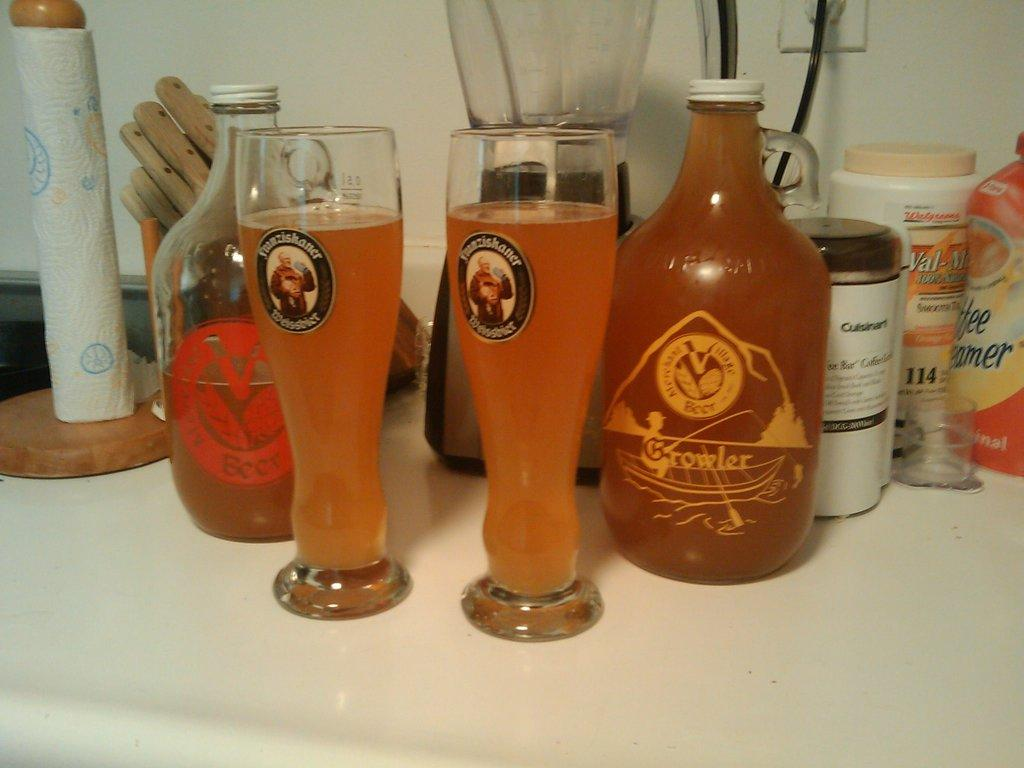Provide a one-sentence caption for the provided image. Two large glasses of beer sit next to a bottle that says Growler on its front. 